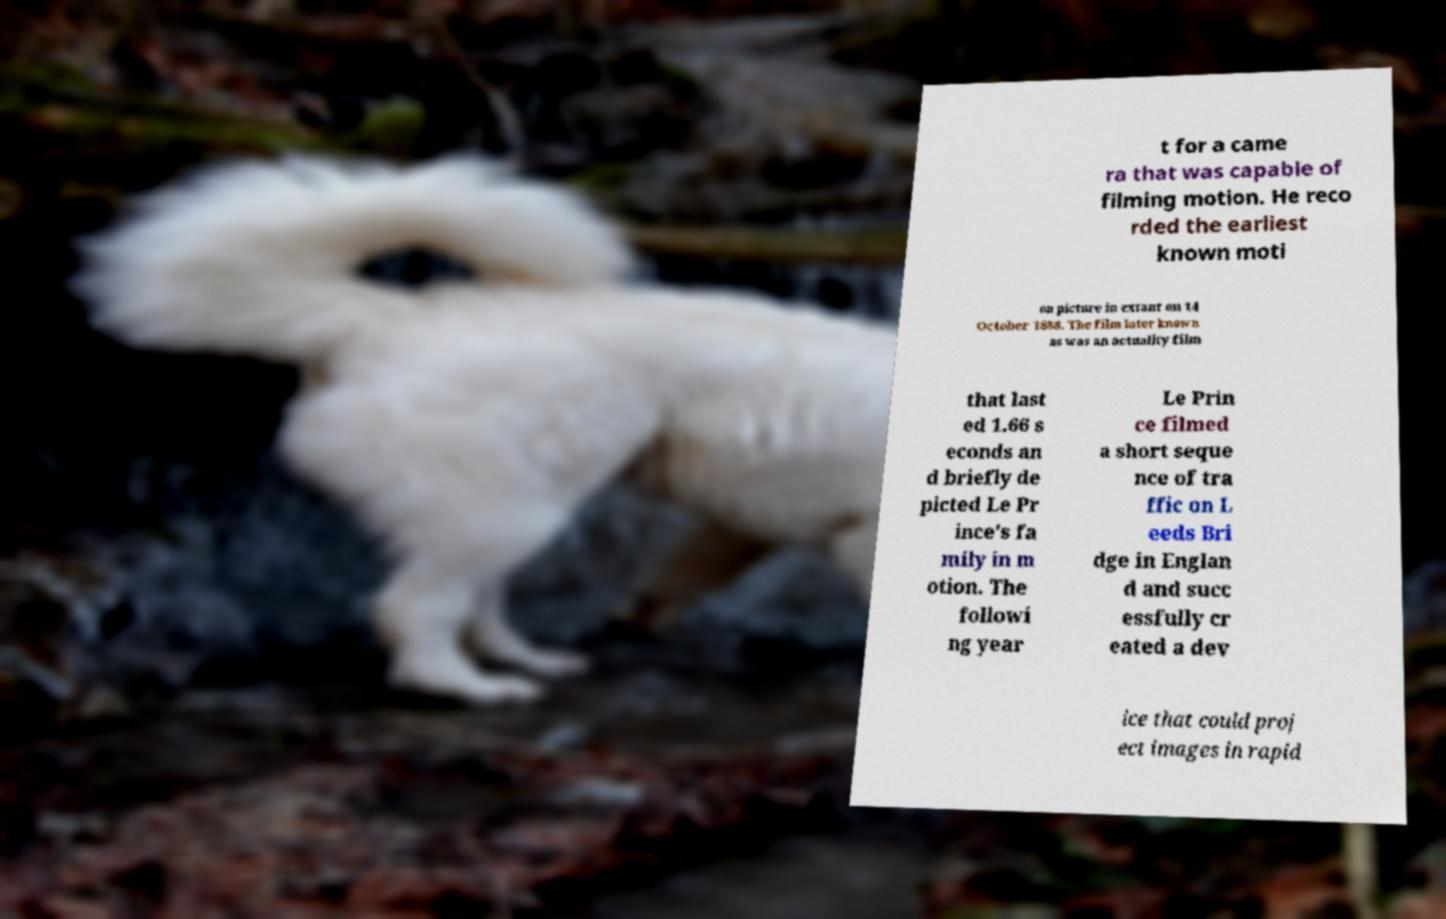Can you read and provide the text displayed in the image?This photo seems to have some interesting text. Can you extract and type it out for me? t for a came ra that was capable of filming motion. He reco rded the earliest known moti on picture in extant on 14 October 1888. The film later known as was an actuality film that last ed 1.66 s econds an d briefly de picted Le Pr ince's fa mily in m otion. The followi ng year Le Prin ce filmed a short seque nce of tra ffic on L eeds Bri dge in Englan d and succ essfully cr eated a dev ice that could proj ect images in rapid 